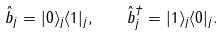<formula> <loc_0><loc_0><loc_500><loc_500>\hat { b } _ { j } = | 0 \rangle _ { j } \langle 1 | _ { j } , \quad \hat { b } _ { j } ^ { \dag } = | 1 \rangle _ { j } \langle 0 | _ { j } .</formula> 